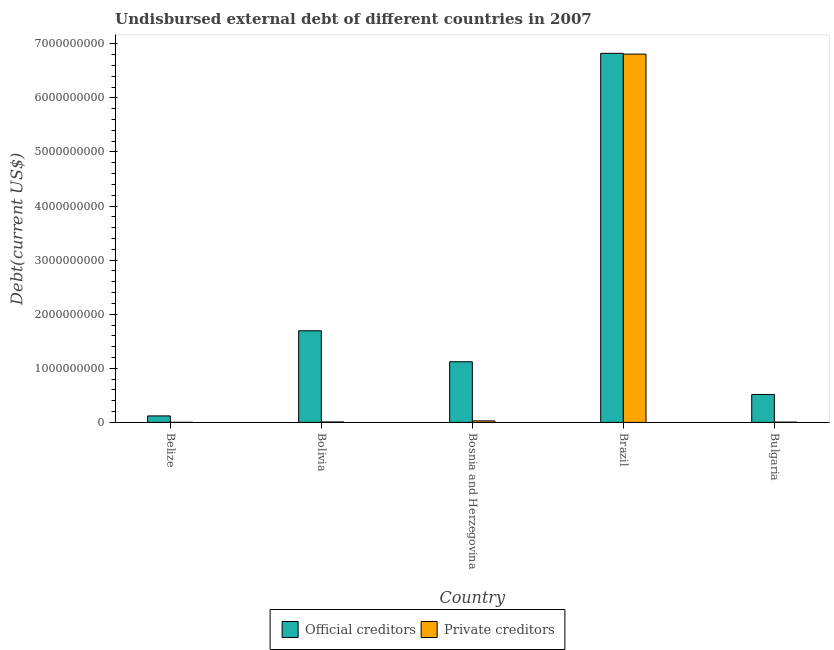How many different coloured bars are there?
Offer a terse response. 2. How many groups of bars are there?
Your answer should be compact. 5. How many bars are there on the 3rd tick from the left?
Offer a very short reply. 2. How many bars are there on the 4th tick from the right?
Your response must be concise. 2. What is the label of the 1st group of bars from the left?
Your response must be concise. Belize. What is the undisbursed external debt of official creditors in Bosnia and Herzegovina?
Ensure brevity in your answer.  1.12e+09. Across all countries, what is the maximum undisbursed external debt of private creditors?
Offer a very short reply. 6.81e+09. Across all countries, what is the minimum undisbursed external debt of private creditors?
Offer a terse response. 8.41e+05. In which country was the undisbursed external debt of official creditors maximum?
Ensure brevity in your answer.  Brazil. In which country was the undisbursed external debt of private creditors minimum?
Offer a terse response. Belize. What is the total undisbursed external debt of private creditors in the graph?
Your answer should be compact. 6.85e+09. What is the difference between the undisbursed external debt of private creditors in Belize and that in Brazil?
Give a very brief answer. -6.81e+09. What is the difference between the undisbursed external debt of official creditors in Belize and the undisbursed external debt of private creditors in Bosnia and Herzegovina?
Provide a short and direct response. 9.19e+07. What is the average undisbursed external debt of official creditors per country?
Keep it short and to the point. 2.06e+09. What is the difference between the undisbursed external debt of private creditors and undisbursed external debt of official creditors in Brazil?
Keep it short and to the point. -1.45e+07. In how many countries, is the undisbursed external debt of private creditors greater than 5200000000 US$?
Your answer should be very brief. 1. What is the ratio of the undisbursed external debt of private creditors in Bolivia to that in Bosnia and Herzegovina?
Provide a short and direct response. 0.27. What is the difference between the highest and the second highest undisbursed external debt of official creditors?
Give a very brief answer. 5.13e+09. What is the difference between the highest and the lowest undisbursed external debt of private creditors?
Make the answer very short. 6.81e+09. Is the sum of the undisbursed external debt of official creditors in Belize and Bolivia greater than the maximum undisbursed external debt of private creditors across all countries?
Provide a short and direct response. No. What does the 1st bar from the left in Bolivia represents?
Make the answer very short. Official creditors. What does the 1st bar from the right in Brazil represents?
Make the answer very short. Private creditors. Are all the bars in the graph horizontal?
Make the answer very short. No. How many countries are there in the graph?
Provide a short and direct response. 5. Does the graph contain grids?
Your answer should be very brief. No. What is the title of the graph?
Give a very brief answer. Undisbursed external debt of different countries in 2007. What is the label or title of the Y-axis?
Your response must be concise. Debt(current US$). What is the Debt(current US$) of Official creditors in Belize?
Give a very brief answer. 1.20e+08. What is the Debt(current US$) of Private creditors in Belize?
Offer a terse response. 8.41e+05. What is the Debt(current US$) of Official creditors in Bolivia?
Offer a very short reply. 1.69e+09. What is the Debt(current US$) of Private creditors in Bolivia?
Provide a succinct answer. 7.66e+06. What is the Debt(current US$) in Official creditors in Bosnia and Herzegovina?
Your answer should be very brief. 1.12e+09. What is the Debt(current US$) in Private creditors in Bosnia and Herzegovina?
Offer a terse response. 2.80e+07. What is the Debt(current US$) in Official creditors in Brazil?
Keep it short and to the point. 6.82e+09. What is the Debt(current US$) in Private creditors in Brazil?
Offer a very short reply. 6.81e+09. What is the Debt(current US$) in Official creditors in Bulgaria?
Your answer should be very brief. 5.17e+08. What is the Debt(current US$) in Private creditors in Bulgaria?
Provide a succinct answer. 4.57e+06. Across all countries, what is the maximum Debt(current US$) of Official creditors?
Ensure brevity in your answer.  6.82e+09. Across all countries, what is the maximum Debt(current US$) of Private creditors?
Provide a short and direct response. 6.81e+09. Across all countries, what is the minimum Debt(current US$) of Official creditors?
Ensure brevity in your answer.  1.20e+08. Across all countries, what is the minimum Debt(current US$) of Private creditors?
Provide a short and direct response. 8.41e+05. What is the total Debt(current US$) in Official creditors in the graph?
Offer a terse response. 1.03e+1. What is the total Debt(current US$) in Private creditors in the graph?
Provide a succinct answer. 6.85e+09. What is the difference between the Debt(current US$) in Official creditors in Belize and that in Bolivia?
Keep it short and to the point. -1.57e+09. What is the difference between the Debt(current US$) in Private creditors in Belize and that in Bolivia?
Provide a short and direct response. -6.82e+06. What is the difference between the Debt(current US$) in Official creditors in Belize and that in Bosnia and Herzegovina?
Your response must be concise. -1.00e+09. What is the difference between the Debt(current US$) of Private creditors in Belize and that in Bosnia and Herzegovina?
Make the answer very short. -2.71e+07. What is the difference between the Debt(current US$) in Official creditors in Belize and that in Brazil?
Provide a succinct answer. -6.70e+09. What is the difference between the Debt(current US$) of Private creditors in Belize and that in Brazil?
Your answer should be compact. -6.81e+09. What is the difference between the Debt(current US$) in Official creditors in Belize and that in Bulgaria?
Give a very brief answer. -3.97e+08. What is the difference between the Debt(current US$) in Private creditors in Belize and that in Bulgaria?
Your response must be concise. -3.73e+06. What is the difference between the Debt(current US$) of Official creditors in Bolivia and that in Bosnia and Herzegovina?
Provide a short and direct response. 5.73e+08. What is the difference between the Debt(current US$) in Private creditors in Bolivia and that in Bosnia and Herzegovina?
Your response must be concise. -2.03e+07. What is the difference between the Debt(current US$) in Official creditors in Bolivia and that in Brazil?
Keep it short and to the point. -5.13e+09. What is the difference between the Debt(current US$) in Private creditors in Bolivia and that in Brazil?
Your answer should be compact. -6.80e+09. What is the difference between the Debt(current US$) in Official creditors in Bolivia and that in Bulgaria?
Your response must be concise. 1.18e+09. What is the difference between the Debt(current US$) in Private creditors in Bolivia and that in Bulgaria?
Provide a succinct answer. 3.10e+06. What is the difference between the Debt(current US$) in Official creditors in Bosnia and Herzegovina and that in Brazil?
Provide a succinct answer. -5.70e+09. What is the difference between the Debt(current US$) in Private creditors in Bosnia and Herzegovina and that in Brazil?
Ensure brevity in your answer.  -6.78e+09. What is the difference between the Debt(current US$) of Official creditors in Bosnia and Herzegovina and that in Bulgaria?
Your answer should be very brief. 6.05e+08. What is the difference between the Debt(current US$) in Private creditors in Bosnia and Herzegovina and that in Bulgaria?
Ensure brevity in your answer.  2.34e+07. What is the difference between the Debt(current US$) in Official creditors in Brazil and that in Bulgaria?
Give a very brief answer. 6.31e+09. What is the difference between the Debt(current US$) in Private creditors in Brazil and that in Bulgaria?
Your response must be concise. 6.81e+09. What is the difference between the Debt(current US$) in Official creditors in Belize and the Debt(current US$) in Private creditors in Bolivia?
Provide a short and direct response. 1.12e+08. What is the difference between the Debt(current US$) of Official creditors in Belize and the Debt(current US$) of Private creditors in Bosnia and Herzegovina?
Your response must be concise. 9.19e+07. What is the difference between the Debt(current US$) in Official creditors in Belize and the Debt(current US$) in Private creditors in Brazil?
Offer a very short reply. -6.69e+09. What is the difference between the Debt(current US$) of Official creditors in Belize and the Debt(current US$) of Private creditors in Bulgaria?
Your response must be concise. 1.15e+08. What is the difference between the Debt(current US$) in Official creditors in Bolivia and the Debt(current US$) in Private creditors in Bosnia and Herzegovina?
Offer a terse response. 1.67e+09. What is the difference between the Debt(current US$) in Official creditors in Bolivia and the Debt(current US$) in Private creditors in Brazil?
Your answer should be compact. -5.12e+09. What is the difference between the Debt(current US$) in Official creditors in Bolivia and the Debt(current US$) in Private creditors in Bulgaria?
Make the answer very short. 1.69e+09. What is the difference between the Debt(current US$) of Official creditors in Bosnia and Herzegovina and the Debt(current US$) of Private creditors in Brazil?
Provide a short and direct response. -5.69e+09. What is the difference between the Debt(current US$) of Official creditors in Bosnia and Herzegovina and the Debt(current US$) of Private creditors in Bulgaria?
Offer a very short reply. 1.12e+09. What is the difference between the Debt(current US$) in Official creditors in Brazil and the Debt(current US$) in Private creditors in Bulgaria?
Ensure brevity in your answer.  6.82e+09. What is the average Debt(current US$) of Official creditors per country?
Keep it short and to the point. 2.06e+09. What is the average Debt(current US$) in Private creditors per country?
Keep it short and to the point. 1.37e+09. What is the difference between the Debt(current US$) in Official creditors and Debt(current US$) in Private creditors in Belize?
Your answer should be very brief. 1.19e+08. What is the difference between the Debt(current US$) of Official creditors and Debt(current US$) of Private creditors in Bolivia?
Offer a very short reply. 1.69e+09. What is the difference between the Debt(current US$) of Official creditors and Debt(current US$) of Private creditors in Bosnia and Herzegovina?
Your answer should be compact. 1.09e+09. What is the difference between the Debt(current US$) in Official creditors and Debt(current US$) in Private creditors in Brazil?
Your answer should be very brief. 1.45e+07. What is the difference between the Debt(current US$) of Official creditors and Debt(current US$) of Private creditors in Bulgaria?
Ensure brevity in your answer.  5.12e+08. What is the ratio of the Debt(current US$) of Official creditors in Belize to that in Bolivia?
Provide a short and direct response. 0.07. What is the ratio of the Debt(current US$) of Private creditors in Belize to that in Bolivia?
Make the answer very short. 0.11. What is the ratio of the Debt(current US$) of Official creditors in Belize to that in Bosnia and Herzegovina?
Provide a succinct answer. 0.11. What is the ratio of the Debt(current US$) of Private creditors in Belize to that in Bosnia and Herzegovina?
Keep it short and to the point. 0.03. What is the ratio of the Debt(current US$) in Official creditors in Belize to that in Brazil?
Provide a short and direct response. 0.02. What is the ratio of the Debt(current US$) in Official creditors in Belize to that in Bulgaria?
Provide a short and direct response. 0.23. What is the ratio of the Debt(current US$) in Private creditors in Belize to that in Bulgaria?
Provide a short and direct response. 0.18. What is the ratio of the Debt(current US$) in Official creditors in Bolivia to that in Bosnia and Herzegovina?
Offer a terse response. 1.51. What is the ratio of the Debt(current US$) in Private creditors in Bolivia to that in Bosnia and Herzegovina?
Provide a succinct answer. 0.27. What is the ratio of the Debt(current US$) of Official creditors in Bolivia to that in Brazil?
Ensure brevity in your answer.  0.25. What is the ratio of the Debt(current US$) in Private creditors in Bolivia to that in Brazil?
Offer a very short reply. 0. What is the ratio of the Debt(current US$) of Official creditors in Bolivia to that in Bulgaria?
Your answer should be compact. 3.28. What is the ratio of the Debt(current US$) in Private creditors in Bolivia to that in Bulgaria?
Offer a terse response. 1.68. What is the ratio of the Debt(current US$) of Official creditors in Bosnia and Herzegovina to that in Brazil?
Ensure brevity in your answer.  0.16. What is the ratio of the Debt(current US$) in Private creditors in Bosnia and Herzegovina to that in Brazil?
Offer a terse response. 0. What is the ratio of the Debt(current US$) of Official creditors in Bosnia and Herzegovina to that in Bulgaria?
Ensure brevity in your answer.  2.17. What is the ratio of the Debt(current US$) of Private creditors in Bosnia and Herzegovina to that in Bulgaria?
Your response must be concise. 6.12. What is the ratio of the Debt(current US$) in Official creditors in Brazil to that in Bulgaria?
Your answer should be very brief. 13.21. What is the ratio of the Debt(current US$) of Private creditors in Brazil to that in Bulgaria?
Ensure brevity in your answer.  1490.81. What is the difference between the highest and the second highest Debt(current US$) of Official creditors?
Ensure brevity in your answer.  5.13e+09. What is the difference between the highest and the second highest Debt(current US$) of Private creditors?
Provide a succinct answer. 6.78e+09. What is the difference between the highest and the lowest Debt(current US$) of Official creditors?
Give a very brief answer. 6.70e+09. What is the difference between the highest and the lowest Debt(current US$) of Private creditors?
Offer a very short reply. 6.81e+09. 